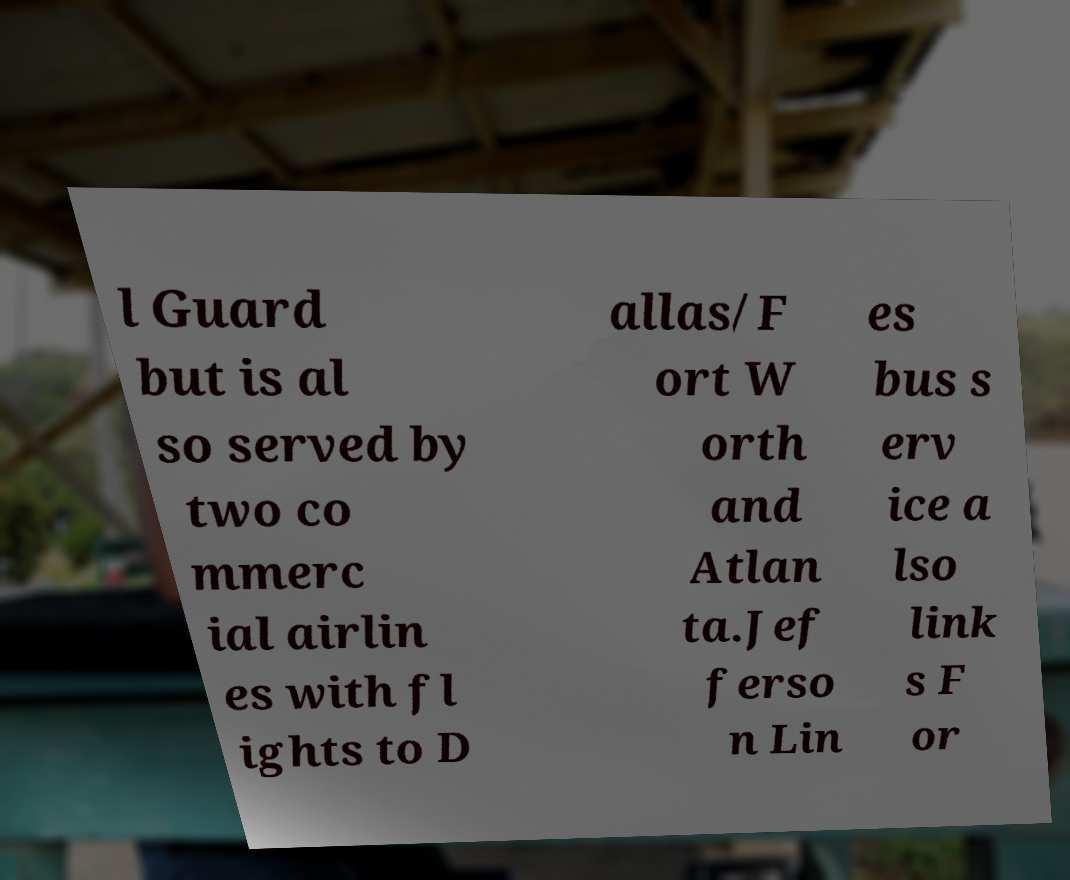Please read and relay the text visible in this image. What does it say? l Guard but is al so served by two co mmerc ial airlin es with fl ights to D allas/F ort W orth and Atlan ta.Jef ferso n Lin es bus s erv ice a lso link s F or 